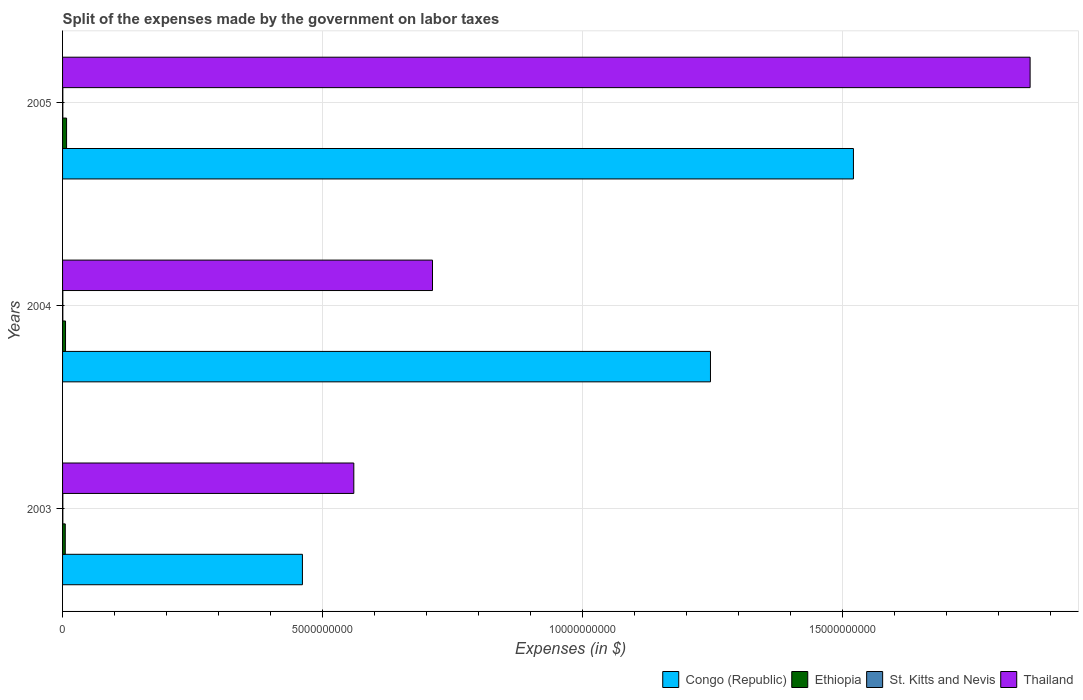How many groups of bars are there?
Your answer should be very brief. 3. Are the number of bars per tick equal to the number of legend labels?
Offer a very short reply. Yes. Are the number of bars on each tick of the Y-axis equal?
Make the answer very short. Yes. How many bars are there on the 3rd tick from the bottom?
Offer a very short reply. 4. What is the expenses made by the government on labor taxes in Congo (Republic) in 2005?
Your response must be concise. 1.52e+1. Across all years, what is the maximum expenses made by the government on labor taxes in Thailand?
Provide a short and direct response. 1.86e+1. In which year was the expenses made by the government on labor taxes in Thailand minimum?
Provide a succinct answer. 2003. What is the total expenses made by the government on labor taxes in Ethiopia in the graph?
Ensure brevity in your answer.  1.86e+08. What is the difference between the expenses made by the government on labor taxes in Congo (Republic) in 2003 and that in 2005?
Provide a short and direct response. -1.06e+1. What is the difference between the expenses made by the government on labor taxes in Congo (Republic) in 2004 and the expenses made by the government on labor taxes in St. Kitts and Nevis in 2003?
Offer a very short reply. 1.25e+1. What is the average expenses made by the government on labor taxes in St. Kitts and Nevis per year?
Your answer should be very brief. 5.10e+06. In the year 2004, what is the difference between the expenses made by the government on labor taxes in Ethiopia and expenses made by the government on labor taxes in Thailand?
Your answer should be very brief. -7.06e+09. In how many years, is the expenses made by the government on labor taxes in Congo (Republic) greater than 2000000000 $?
Offer a very short reply. 3. What is the ratio of the expenses made by the government on labor taxes in Ethiopia in 2003 to that in 2005?
Keep it short and to the point. 0.67. What is the difference between the highest and the lowest expenses made by the government on labor taxes in Congo (Republic)?
Give a very brief answer. 1.06e+1. In how many years, is the expenses made by the government on labor taxes in St. Kitts and Nevis greater than the average expenses made by the government on labor taxes in St. Kitts and Nevis taken over all years?
Provide a succinct answer. 1. What does the 3rd bar from the top in 2003 represents?
Make the answer very short. Ethiopia. What does the 3rd bar from the bottom in 2004 represents?
Make the answer very short. St. Kitts and Nevis. How many bars are there?
Your answer should be very brief. 12. How many years are there in the graph?
Offer a very short reply. 3. Are the values on the major ticks of X-axis written in scientific E-notation?
Make the answer very short. No. Does the graph contain any zero values?
Your answer should be very brief. No. Where does the legend appear in the graph?
Offer a terse response. Bottom right. What is the title of the graph?
Offer a terse response. Split of the expenses made by the government on labor taxes. Does "Andorra" appear as one of the legend labels in the graph?
Your response must be concise. No. What is the label or title of the X-axis?
Your answer should be compact. Expenses (in $). What is the label or title of the Y-axis?
Make the answer very short. Years. What is the Expenses (in $) in Congo (Republic) in 2003?
Provide a succinct answer. 4.61e+09. What is the Expenses (in $) of Ethiopia in 2003?
Provide a short and direct response. 5.20e+07. What is the Expenses (in $) of St. Kitts and Nevis in 2003?
Provide a succinct answer. 5.20e+06. What is the Expenses (in $) of Thailand in 2003?
Your answer should be very brief. 5.60e+09. What is the Expenses (in $) of Congo (Republic) in 2004?
Your response must be concise. 1.25e+1. What is the Expenses (in $) of Ethiopia in 2004?
Your response must be concise. 5.71e+07. What is the Expenses (in $) in St. Kitts and Nevis in 2004?
Provide a short and direct response. 5.10e+06. What is the Expenses (in $) in Thailand in 2004?
Give a very brief answer. 7.12e+09. What is the Expenses (in $) in Congo (Republic) in 2005?
Offer a terse response. 1.52e+1. What is the Expenses (in $) in Ethiopia in 2005?
Provide a succinct answer. 7.71e+07. What is the Expenses (in $) of Thailand in 2005?
Provide a succinct answer. 1.86e+1. Across all years, what is the maximum Expenses (in $) in Congo (Republic)?
Your response must be concise. 1.52e+1. Across all years, what is the maximum Expenses (in $) in Ethiopia?
Ensure brevity in your answer.  7.71e+07. Across all years, what is the maximum Expenses (in $) of St. Kitts and Nevis?
Give a very brief answer. 5.20e+06. Across all years, what is the maximum Expenses (in $) in Thailand?
Provide a succinct answer. 1.86e+1. Across all years, what is the minimum Expenses (in $) in Congo (Republic)?
Offer a very short reply. 4.61e+09. Across all years, what is the minimum Expenses (in $) in Ethiopia?
Offer a terse response. 5.20e+07. Across all years, what is the minimum Expenses (in $) in Thailand?
Your answer should be compact. 5.60e+09. What is the total Expenses (in $) of Congo (Republic) in the graph?
Your response must be concise. 3.23e+1. What is the total Expenses (in $) in Ethiopia in the graph?
Ensure brevity in your answer.  1.86e+08. What is the total Expenses (in $) in St. Kitts and Nevis in the graph?
Offer a very short reply. 1.53e+07. What is the total Expenses (in $) of Thailand in the graph?
Offer a very short reply. 3.13e+1. What is the difference between the Expenses (in $) of Congo (Republic) in 2003 and that in 2004?
Provide a short and direct response. -7.85e+09. What is the difference between the Expenses (in $) of Ethiopia in 2003 and that in 2004?
Ensure brevity in your answer.  -5.10e+06. What is the difference between the Expenses (in $) in St. Kitts and Nevis in 2003 and that in 2004?
Offer a very short reply. 1.00e+05. What is the difference between the Expenses (in $) in Thailand in 2003 and that in 2004?
Offer a very short reply. -1.51e+09. What is the difference between the Expenses (in $) of Congo (Republic) in 2003 and that in 2005?
Offer a terse response. -1.06e+1. What is the difference between the Expenses (in $) in Ethiopia in 2003 and that in 2005?
Keep it short and to the point. -2.51e+07. What is the difference between the Expenses (in $) in St. Kitts and Nevis in 2003 and that in 2005?
Make the answer very short. 2.00e+05. What is the difference between the Expenses (in $) in Thailand in 2003 and that in 2005?
Your response must be concise. -1.30e+1. What is the difference between the Expenses (in $) in Congo (Republic) in 2004 and that in 2005?
Make the answer very short. -2.75e+09. What is the difference between the Expenses (in $) in Ethiopia in 2004 and that in 2005?
Keep it short and to the point. -2.00e+07. What is the difference between the Expenses (in $) in St. Kitts and Nevis in 2004 and that in 2005?
Your answer should be very brief. 1.00e+05. What is the difference between the Expenses (in $) in Thailand in 2004 and that in 2005?
Your answer should be very brief. -1.15e+1. What is the difference between the Expenses (in $) in Congo (Republic) in 2003 and the Expenses (in $) in Ethiopia in 2004?
Provide a short and direct response. 4.56e+09. What is the difference between the Expenses (in $) of Congo (Republic) in 2003 and the Expenses (in $) of St. Kitts and Nevis in 2004?
Ensure brevity in your answer.  4.61e+09. What is the difference between the Expenses (in $) in Congo (Republic) in 2003 and the Expenses (in $) in Thailand in 2004?
Your response must be concise. -2.50e+09. What is the difference between the Expenses (in $) of Ethiopia in 2003 and the Expenses (in $) of St. Kitts and Nevis in 2004?
Your answer should be compact. 4.69e+07. What is the difference between the Expenses (in $) in Ethiopia in 2003 and the Expenses (in $) in Thailand in 2004?
Your response must be concise. -7.06e+09. What is the difference between the Expenses (in $) in St. Kitts and Nevis in 2003 and the Expenses (in $) in Thailand in 2004?
Give a very brief answer. -7.11e+09. What is the difference between the Expenses (in $) in Congo (Republic) in 2003 and the Expenses (in $) in Ethiopia in 2005?
Offer a terse response. 4.54e+09. What is the difference between the Expenses (in $) of Congo (Republic) in 2003 and the Expenses (in $) of St. Kitts and Nevis in 2005?
Keep it short and to the point. 4.61e+09. What is the difference between the Expenses (in $) in Congo (Republic) in 2003 and the Expenses (in $) in Thailand in 2005?
Keep it short and to the point. -1.40e+1. What is the difference between the Expenses (in $) in Ethiopia in 2003 and the Expenses (in $) in St. Kitts and Nevis in 2005?
Your answer should be compact. 4.70e+07. What is the difference between the Expenses (in $) of Ethiopia in 2003 and the Expenses (in $) of Thailand in 2005?
Provide a succinct answer. -1.86e+1. What is the difference between the Expenses (in $) in St. Kitts and Nevis in 2003 and the Expenses (in $) in Thailand in 2005?
Keep it short and to the point. -1.86e+1. What is the difference between the Expenses (in $) of Congo (Republic) in 2004 and the Expenses (in $) of Ethiopia in 2005?
Ensure brevity in your answer.  1.24e+1. What is the difference between the Expenses (in $) of Congo (Republic) in 2004 and the Expenses (in $) of St. Kitts and Nevis in 2005?
Give a very brief answer. 1.25e+1. What is the difference between the Expenses (in $) of Congo (Republic) in 2004 and the Expenses (in $) of Thailand in 2005?
Your answer should be compact. -6.15e+09. What is the difference between the Expenses (in $) of Ethiopia in 2004 and the Expenses (in $) of St. Kitts and Nevis in 2005?
Provide a succinct answer. 5.21e+07. What is the difference between the Expenses (in $) of Ethiopia in 2004 and the Expenses (in $) of Thailand in 2005?
Your answer should be very brief. -1.86e+1. What is the difference between the Expenses (in $) in St. Kitts and Nevis in 2004 and the Expenses (in $) in Thailand in 2005?
Keep it short and to the point. -1.86e+1. What is the average Expenses (in $) of Congo (Republic) per year?
Provide a succinct answer. 1.08e+1. What is the average Expenses (in $) of Ethiopia per year?
Your answer should be compact. 6.21e+07. What is the average Expenses (in $) of St. Kitts and Nevis per year?
Offer a terse response. 5.10e+06. What is the average Expenses (in $) in Thailand per year?
Keep it short and to the point. 1.04e+1. In the year 2003, what is the difference between the Expenses (in $) of Congo (Republic) and Expenses (in $) of Ethiopia?
Provide a short and direct response. 4.56e+09. In the year 2003, what is the difference between the Expenses (in $) in Congo (Republic) and Expenses (in $) in St. Kitts and Nevis?
Your answer should be very brief. 4.61e+09. In the year 2003, what is the difference between the Expenses (in $) in Congo (Republic) and Expenses (in $) in Thailand?
Give a very brief answer. -9.89e+08. In the year 2003, what is the difference between the Expenses (in $) in Ethiopia and Expenses (in $) in St. Kitts and Nevis?
Provide a succinct answer. 4.68e+07. In the year 2003, what is the difference between the Expenses (in $) in Ethiopia and Expenses (in $) in Thailand?
Provide a short and direct response. -5.55e+09. In the year 2003, what is the difference between the Expenses (in $) of St. Kitts and Nevis and Expenses (in $) of Thailand?
Ensure brevity in your answer.  -5.60e+09. In the year 2004, what is the difference between the Expenses (in $) in Congo (Republic) and Expenses (in $) in Ethiopia?
Your answer should be compact. 1.24e+1. In the year 2004, what is the difference between the Expenses (in $) in Congo (Republic) and Expenses (in $) in St. Kitts and Nevis?
Ensure brevity in your answer.  1.25e+1. In the year 2004, what is the difference between the Expenses (in $) in Congo (Republic) and Expenses (in $) in Thailand?
Offer a terse response. 5.35e+09. In the year 2004, what is the difference between the Expenses (in $) of Ethiopia and Expenses (in $) of St. Kitts and Nevis?
Make the answer very short. 5.20e+07. In the year 2004, what is the difference between the Expenses (in $) in Ethiopia and Expenses (in $) in Thailand?
Ensure brevity in your answer.  -7.06e+09. In the year 2004, what is the difference between the Expenses (in $) in St. Kitts and Nevis and Expenses (in $) in Thailand?
Your answer should be compact. -7.11e+09. In the year 2005, what is the difference between the Expenses (in $) of Congo (Republic) and Expenses (in $) of Ethiopia?
Ensure brevity in your answer.  1.51e+1. In the year 2005, what is the difference between the Expenses (in $) in Congo (Republic) and Expenses (in $) in St. Kitts and Nevis?
Make the answer very short. 1.52e+1. In the year 2005, what is the difference between the Expenses (in $) in Congo (Republic) and Expenses (in $) in Thailand?
Make the answer very short. -3.40e+09. In the year 2005, what is the difference between the Expenses (in $) in Ethiopia and Expenses (in $) in St. Kitts and Nevis?
Offer a terse response. 7.21e+07. In the year 2005, what is the difference between the Expenses (in $) in Ethiopia and Expenses (in $) in Thailand?
Ensure brevity in your answer.  -1.85e+1. In the year 2005, what is the difference between the Expenses (in $) in St. Kitts and Nevis and Expenses (in $) in Thailand?
Provide a short and direct response. -1.86e+1. What is the ratio of the Expenses (in $) in Congo (Republic) in 2003 to that in 2004?
Make the answer very short. 0.37. What is the ratio of the Expenses (in $) in Ethiopia in 2003 to that in 2004?
Make the answer very short. 0.91. What is the ratio of the Expenses (in $) in St. Kitts and Nevis in 2003 to that in 2004?
Offer a terse response. 1.02. What is the ratio of the Expenses (in $) in Thailand in 2003 to that in 2004?
Make the answer very short. 0.79. What is the ratio of the Expenses (in $) in Congo (Republic) in 2003 to that in 2005?
Provide a short and direct response. 0.3. What is the ratio of the Expenses (in $) of Ethiopia in 2003 to that in 2005?
Make the answer very short. 0.67. What is the ratio of the Expenses (in $) in St. Kitts and Nevis in 2003 to that in 2005?
Your answer should be very brief. 1.04. What is the ratio of the Expenses (in $) of Thailand in 2003 to that in 2005?
Keep it short and to the point. 0.3. What is the ratio of the Expenses (in $) in Congo (Republic) in 2004 to that in 2005?
Offer a terse response. 0.82. What is the ratio of the Expenses (in $) in Ethiopia in 2004 to that in 2005?
Your answer should be compact. 0.74. What is the ratio of the Expenses (in $) of St. Kitts and Nevis in 2004 to that in 2005?
Make the answer very short. 1.02. What is the ratio of the Expenses (in $) in Thailand in 2004 to that in 2005?
Give a very brief answer. 0.38. What is the difference between the highest and the second highest Expenses (in $) in Congo (Republic)?
Your answer should be very brief. 2.75e+09. What is the difference between the highest and the second highest Expenses (in $) in St. Kitts and Nevis?
Make the answer very short. 1.00e+05. What is the difference between the highest and the second highest Expenses (in $) of Thailand?
Ensure brevity in your answer.  1.15e+1. What is the difference between the highest and the lowest Expenses (in $) of Congo (Republic)?
Make the answer very short. 1.06e+1. What is the difference between the highest and the lowest Expenses (in $) of Ethiopia?
Ensure brevity in your answer.  2.51e+07. What is the difference between the highest and the lowest Expenses (in $) of St. Kitts and Nevis?
Make the answer very short. 2.00e+05. What is the difference between the highest and the lowest Expenses (in $) of Thailand?
Provide a succinct answer. 1.30e+1. 